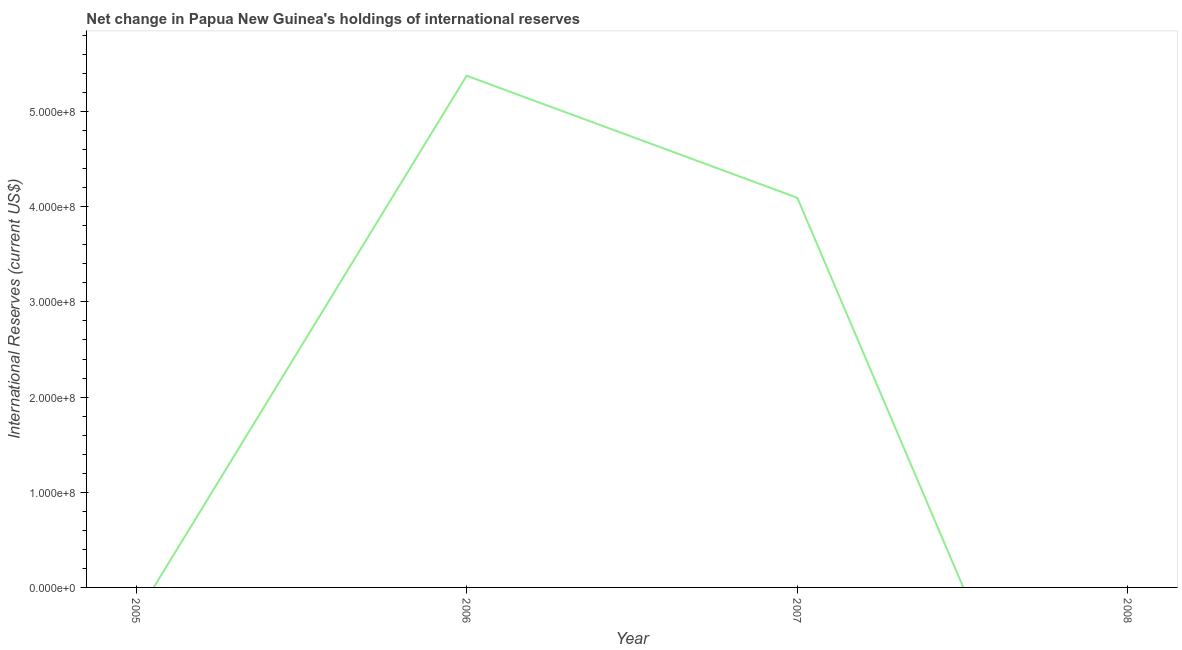Across all years, what is the maximum reserves and related items?
Your answer should be very brief. 5.38e+08. What is the sum of the reserves and related items?
Keep it short and to the point. 9.47e+08. What is the difference between the reserves and related items in 2006 and 2007?
Provide a short and direct response. 1.28e+08. What is the average reserves and related items per year?
Offer a terse response. 2.37e+08. What is the median reserves and related items?
Your answer should be compact. 2.05e+08. Is the reserves and related items in 2006 less than that in 2007?
Provide a succinct answer. No. What is the difference between the highest and the lowest reserves and related items?
Offer a very short reply. 5.38e+08. In how many years, is the reserves and related items greater than the average reserves and related items taken over all years?
Your answer should be compact. 2. How many lines are there?
Offer a terse response. 1. How many years are there in the graph?
Give a very brief answer. 4. What is the title of the graph?
Your answer should be compact. Net change in Papua New Guinea's holdings of international reserves. What is the label or title of the X-axis?
Your answer should be compact. Year. What is the label or title of the Y-axis?
Your answer should be compact. International Reserves (current US$). What is the International Reserves (current US$) in 2006?
Your response must be concise. 5.38e+08. What is the International Reserves (current US$) in 2007?
Provide a succinct answer. 4.09e+08. What is the International Reserves (current US$) in 2008?
Your answer should be very brief. 0. What is the difference between the International Reserves (current US$) in 2006 and 2007?
Your answer should be compact. 1.28e+08. What is the ratio of the International Reserves (current US$) in 2006 to that in 2007?
Ensure brevity in your answer.  1.31. 